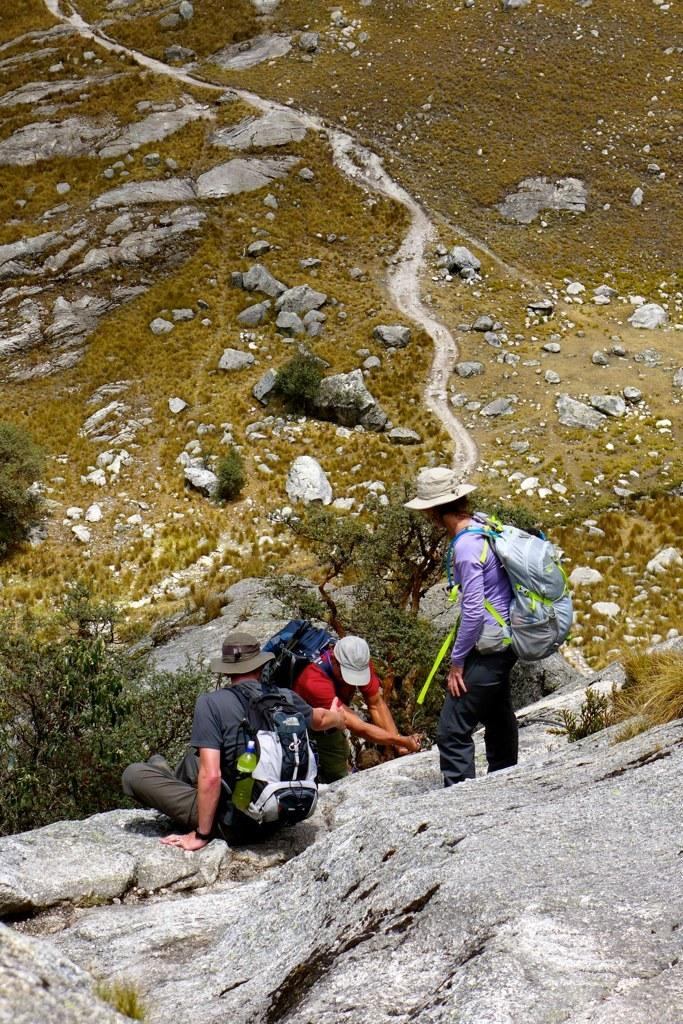How many men are in the image? There are three men in the image. What are the men doing in the image? One man is standing, one man is climbing a rock, and one man is seated on a rock. What are the men wearing on their backs? All three men are wearing backpacks on their backs. What type of vegetation is visible in the image? There are trees visible in the image. What type of spade is the man using to dig in the image? There is no spade present in the image; the men are not digging. What type of key is the man holding in the image? There is no key present in the image; the men are not holding any keys. 